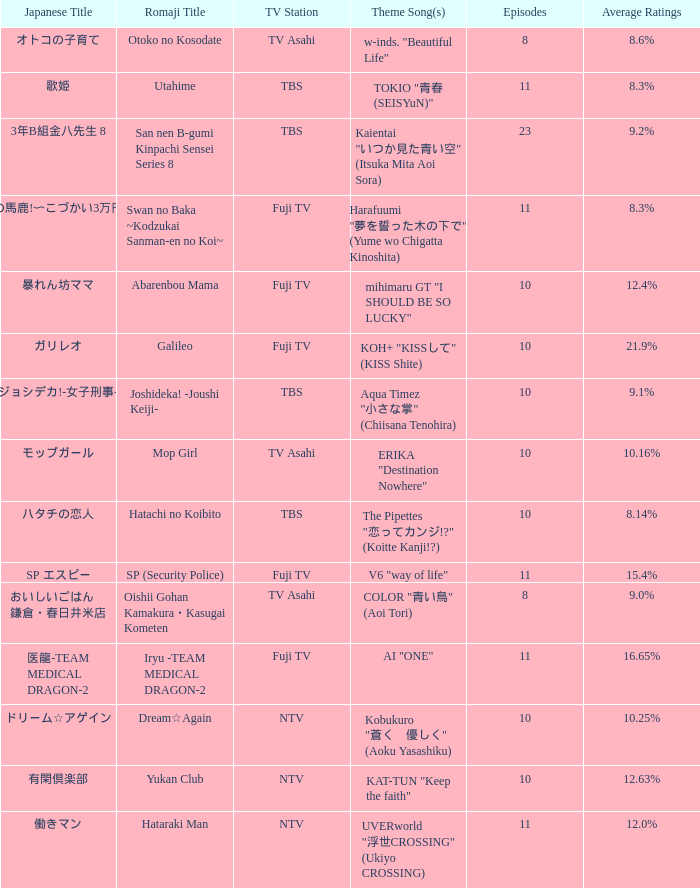What is the Theme Song of 働きマン? UVERworld "浮世CROSSING" (Ukiyo CROSSING). 